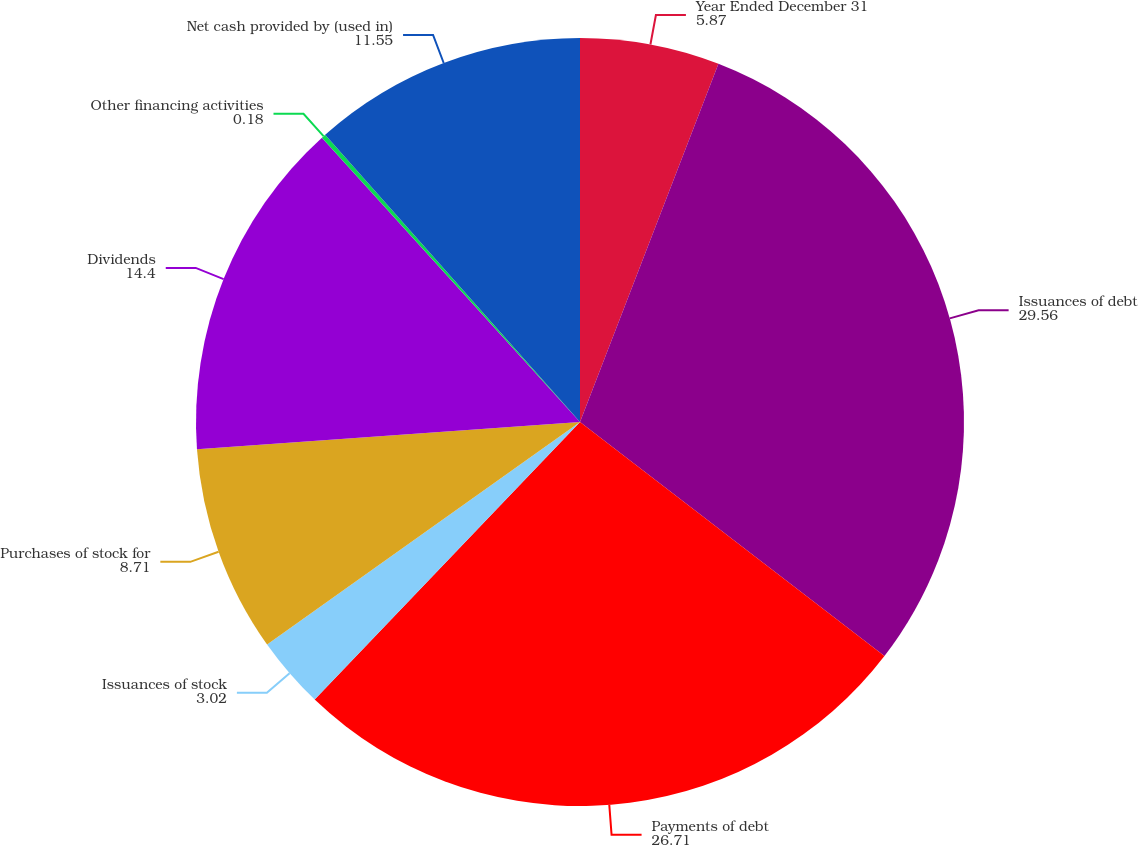<chart> <loc_0><loc_0><loc_500><loc_500><pie_chart><fcel>Year Ended December 31<fcel>Issuances of debt<fcel>Payments of debt<fcel>Issuances of stock<fcel>Purchases of stock for<fcel>Dividends<fcel>Other financing activities<fcel>Net cash provided by (used in)<nl><fcel>5.87%<fcel>29.56%<fcel>26.71%<fcel>3.02%<fcel>8.71%<fcel>14.4%<fcel>0.18%<fcel>11.55%<nl></chart> 